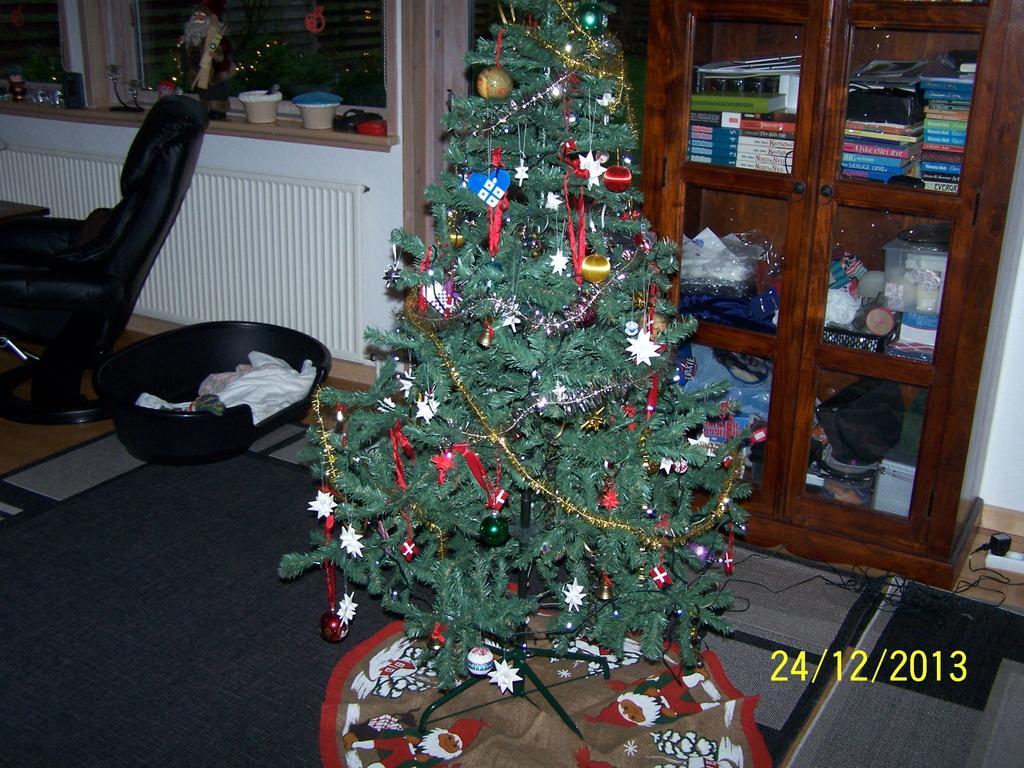How would you summarize this image in a sentence or two? There is a Christmas tree and there is a wooden table which has some books in it behind it. 